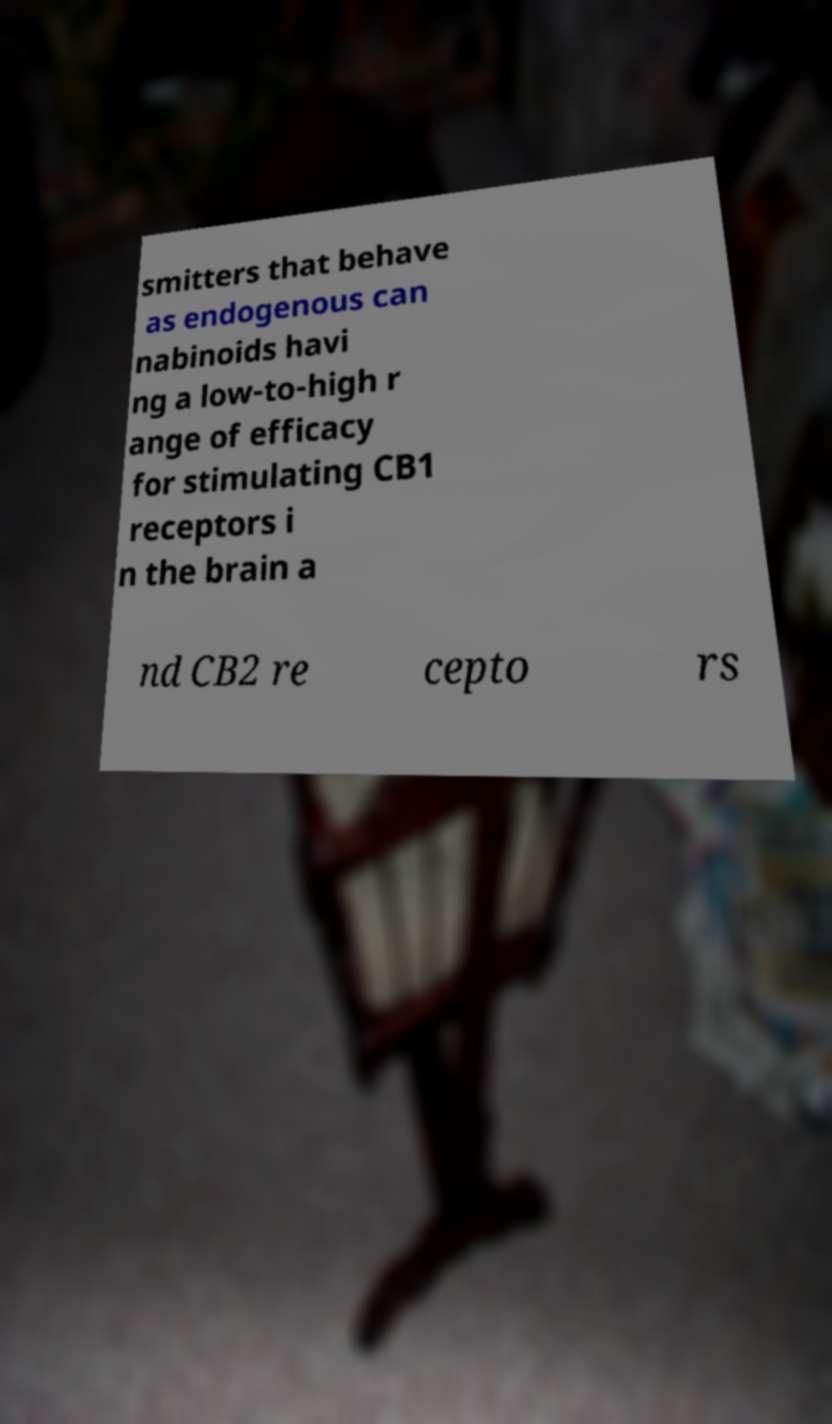Could you extract and type out the text from this image? smitters that behave as endogenous can nabinoids havi ng a low-to-high r ange of efficacy for stimulating CB1 receptors i n the brain a nd CB2 re cepto rs 